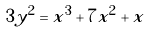Convert formula to latex. <formula><loc_0><loc_0><loc_500><loc_500>3 y ^ { 2 } = x ^ { 3 } + 7 x ^ { 2 } + x</formula> 